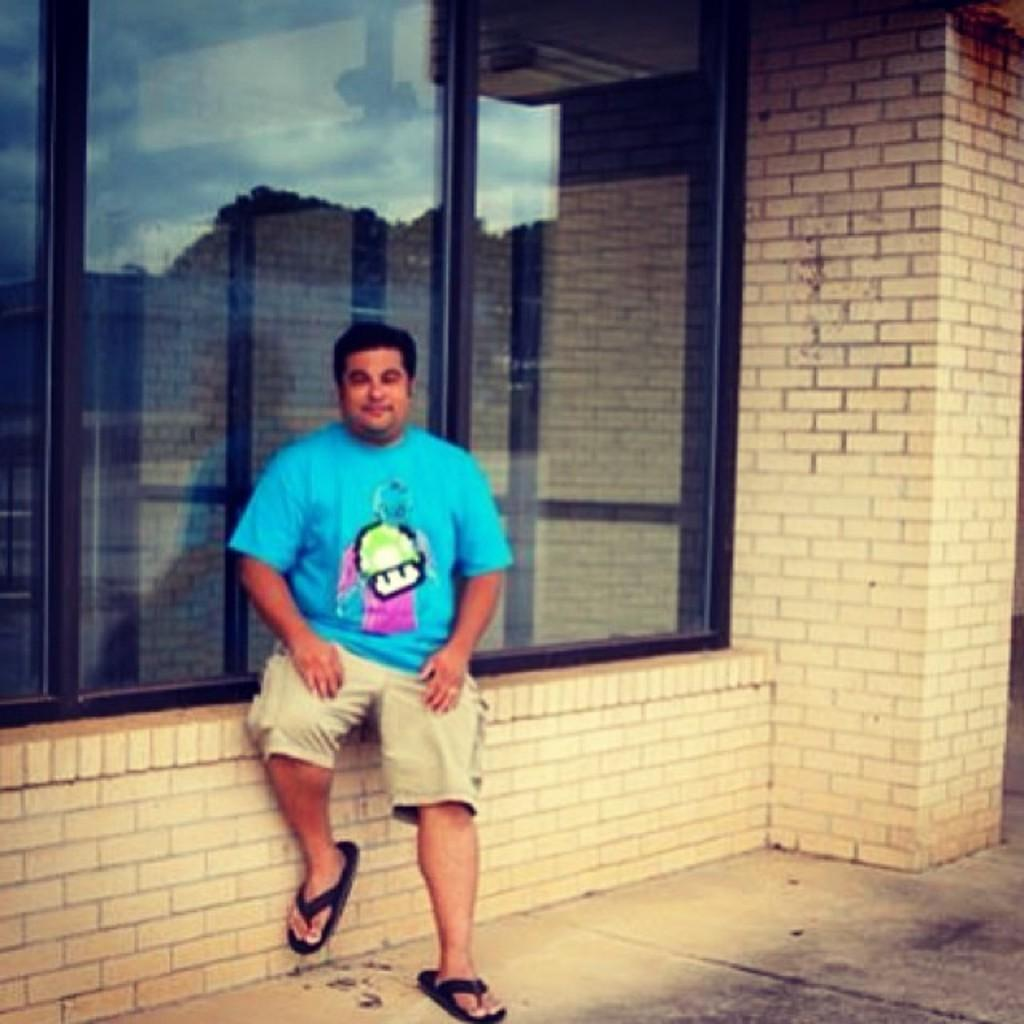What is the man in the image doing? The man is sitting in the image. What can be seen behind the man? There is a wall in the image. What object is present in the image that allows a view of the wall in the background? There is a glass in the image that allows a view of the wall in the background. What can be seen through the glass besides the wall? The sky is visible through the glass. What type of butter is being used to seal the cork in the image? There is no butter or cork present in the image, so this question cannot be answered. 